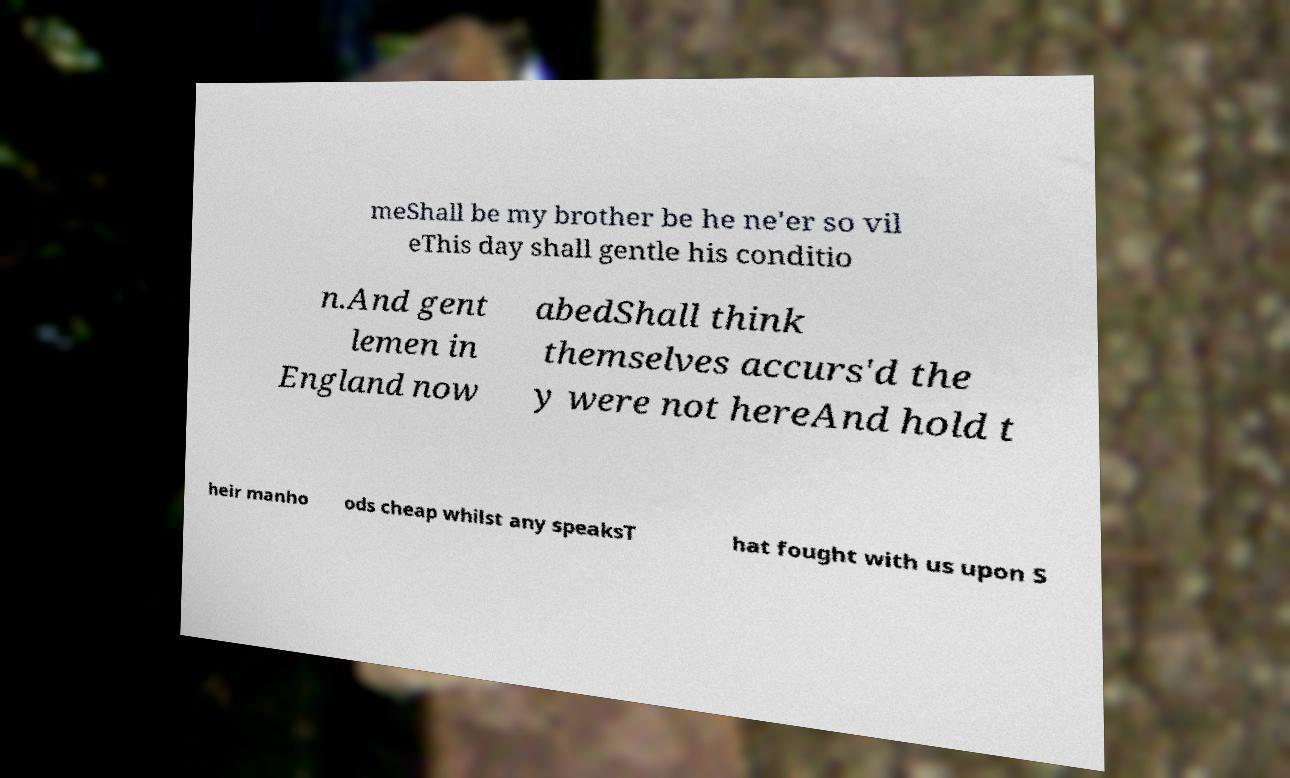I need the written content from this picture converted into text. Can you do that? meShall be my brother be he ne'er so vil eThis day shall gentle his conditio n.And gent lemen in England now abedShall think themselves accurs'd the y were not hereAnd hold t heir manho ods cheap whilst any speaksT hat fought with us upon S 